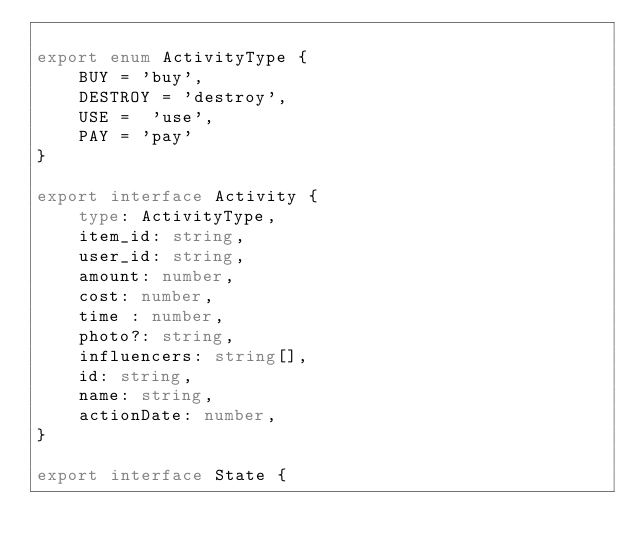<code> <loc_0><loc_0><loc_500><loc_500><_TypeScript_>
export enum ActivityType {
    BUY = 'buy',
    DESTROY = 'destroy',
    USE =  'use',
    PAY = 'pay'
}

export interface Activity {
    type: ActivityType,
    item_id: string,
    user_id: string,
    amount: number,
    cost: number,
    time : number,
    photo?: string,
    influencers: string[],
    id: string, 
    name: string,
    actionDate: number,
}

export interface State {</code> 